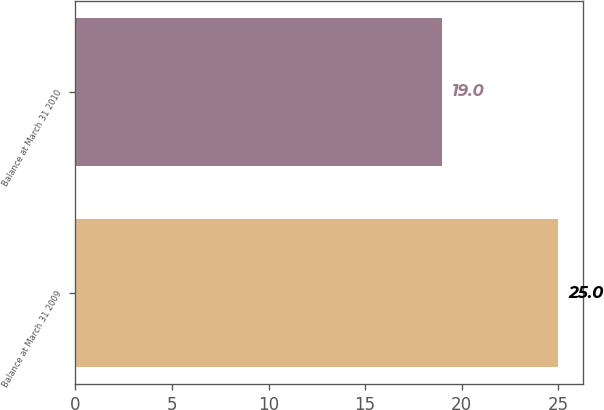Convert chart. <chart><loc_0><loc_0><loc_500><loc_500><bar_chart><fcel>Balance at March 31 2009<fcel>Balance at March 31 2010<nl><fcel>25<fcel>19<nl></chart> 